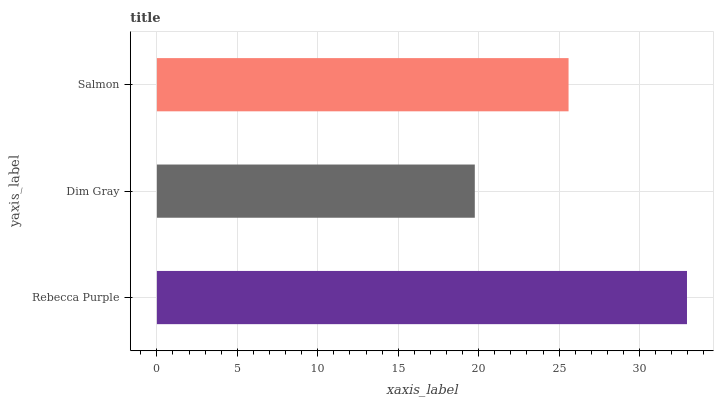Is Dim Gray the minimum?
Answer yes or no. Yes. Is Rebecca Purple the maximum?
Answer yes or no. Yes. Is Salmon the minimum?
Answer yes or no. No. Is Salmon the maximum?
Answer yes or no. No. Is Salmon greater than Dim Gray?
Answer yes or no. Yes. Is Dim Gray less than Salmon?
Answer yes or no. Yes. Is Dim Gray greater than Salmon?
Answer yes or no. No. Is Salmon less than Dim Gray?
Answer yes or no. No. Is Salmon the high median?
Answer yes or no. Yes. Is Salmon the low median?
Answer yes or no. Yes. Is Rebecca Purple the high median?
Answer yes or no. No. Is Rebecca Purple the low median?
Answer yes or no. No. 